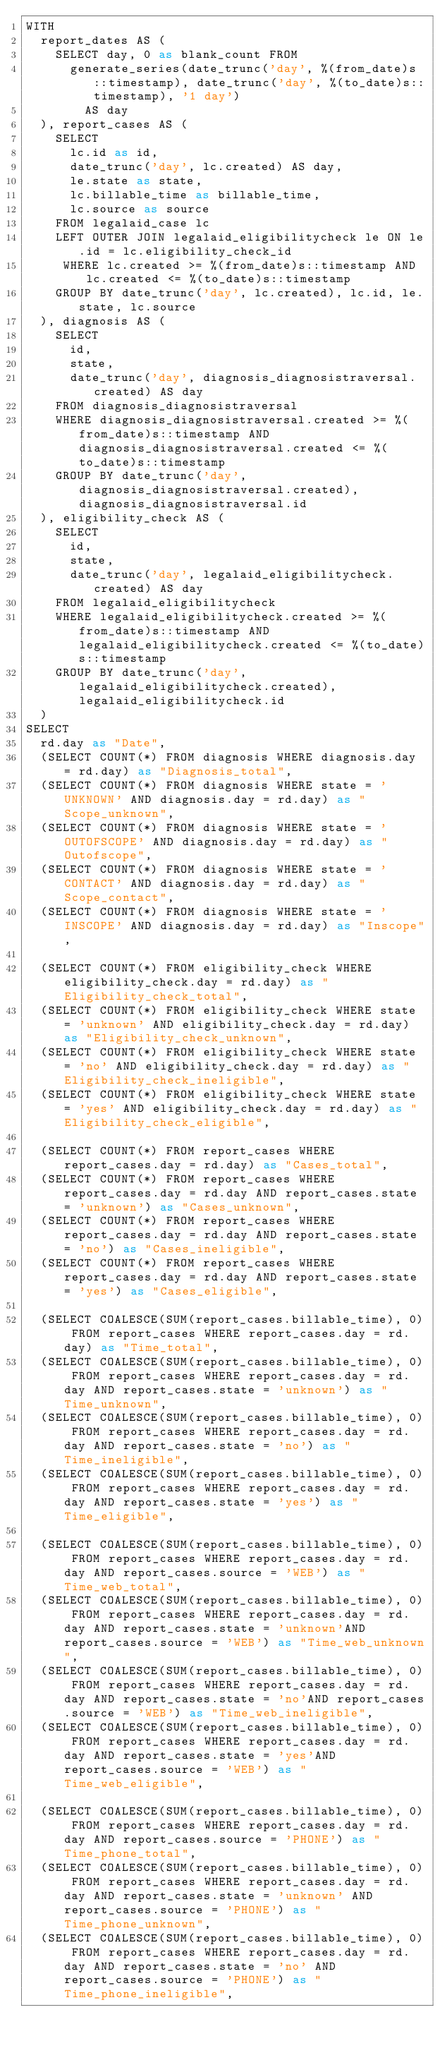<code> <loc_0><loc_0><loc_500><loc_500><_SQL_>WITH
  report_dates AS (
    SELECT day, 0 as blank_count FROM
      generate_series(date_trunc('day', %(from_date)s::timestamp), date_trunc('day', %(to_date)s::timestamp), '1 day')
        AS day
  ), report_cases AS (
    SELECT
      lc.id as id,
      date_trunc('day', lc.created) AS day,
      le.state as state,
      lc.billable_time as billable_time,
      lc.source as source
    FROM legalaid_case lc
    LEFT OUTER JOIN legalaid_eligibilitycheck le ON le.id = lc.eligibility_check_id
     WHERE lc.created >= %(from_date)s::timestamp AND lc.created <= %(to_date)s::timestamp
    GROUP BY date_trunc('day', lc.created), lc.id, le.state, lc.source
  ), diagnosis AS (
    SELECT
      id,
      state,
      date_trunc('day', diagnosis_diagnosistraversal.created) AS day
    FROM diagnosis_diagnosistraversal
    WHERE diagnosis_diagnosistraversal.created >= %(from_date)s::timestamp AND diagnosis_diagnosistraversal.created <= %(to_date)s::timestamp
    GROUP BY date_trunc('day', diagnosis_diagnosistraversal.created), diagnosis_diagnosistraversal.id
  ), eligibility_check AS (
    SELECT
      id,
      state,
      date_trunc('day', legalaid_eligibilitycheck.created) AS day
    FROM legalaid_eligibilitycheck
    WHERE legalaid_eligibilitycheck.created >= %(from_date)s::timestamp AND legalaid_eligibilitycheck.created <= %(to_date)s::timestamp
    GROUP BY date_trunc('day', legalaid_eligibilitycheck.created), legalaid_eligibilitycheck.id
  )
SELECT
  rd.day as "Date",
  (SELECT COUNT(*) FROM diagnosis WHERE diagnosis.day = rd.day) as "Diagnosis_total",
  (SELECT COUNT(*) FROM diagnosis WHERE state = 'UNKNOWN' AND diagnosis.day = rd.day) as "Scope_unknown",
  (SELECT COUNT(*) FROM diagnosis WHERE state = 'OUTOFSCOPE' AND diagnosis.day = rd.day) as "Outofscope",
  (SELECT COUNT(*) FROM diagnosis WHERE state = 'CONTACT' AND diagnosis.day = rd.day) as "Scope_contact",
  (SELECT COUNT(*) FROM diagnosis WHERE state = 'INSCOPE' AND diagnosis.day = rd.day) as "Inscope",
  
  (SELECT COUNT(*) FROM eligibility_check WHERE eligibility_check.day = rd.day) as "Eligibility_check_total",
  (SELECT COUNT(*) FROM eligibility_check WHERE state = 'unknown' AND eligibility_check.day = rd.day) as "Eligibility_check_unknown",
  (SELECT COUNT(*) FROM eligibility_check WHERE state = 'no' AND eligibility_check.day = rd.day) as "Eligibility_check_ineligible",
  (SELECT COUNT(*) FROM eligibility_check WHERE state = 'yes' AND eligibility_check.day = rd.day) as "Eligibility_check_eligible",
  
  (SELECT COUNT(*) FROM report_cases WHERE report_cases.day = rd.day) as "Cases_total",
  (SELECT COUNT(*) FROM report_cases WHERE report_cases.day = rd.day AND report_cases.state = 'unknown') as "Cases_unknown",
  (SELECT COUNT(*) FROM report_cases WHERE report_cases.day = rd.day AND report_cases.state = 'no') as "Cases_ineligible",
  (SELECT COUNT(*) FROM report_cases WHERE report_cases.day = rd.day AND report_cases.state = 'yes') as "Cases_eligible",

  (SELECT COALESCE(SUM(report_cases.billable_time), 0) FROM report_cases WHERE report_cases.day = rd.day) as "Time_total",
  (SELECT COALESCE(SUM(report_cases.billable_time), 0) FROM report_cases WHERE report_cases.day = rd.day AND report_cases.state = 'unknown') as "Time_unknown",
  (SELECT COALESCE(SUM(report_cases.billable_time), 0) FROM report_cases WHERE report_cases.day = rd.day AND report_cases.state = 'no') as "Time_ineligible",
  (SELECT COALESCE(SUM(report_cases.billable_time), 0) FROM report_cases WHERE report_cases.day = rd.day AND report_cases.state = 'yes') as "Time_eligible",

  (SELECT COALESCE(SUM(report_cases.billable_time), 0) FROM report_cases WHERE report_cases.day = rd.day AND report_cases.source = 'WEB') as "Time_web_total",
  (SELECT COALESCE(SUM(report_cases.billable_time), 0) FROM report_cases WHERE report_cases.day = rd.day AND report_cases.state = 'unknown'AND report_cases.source = 'WEB') as "Time_web_unknown",
  (SELECT COALESCE(SUM(report_cases.billable_time), 0) FROM report_cases WHERE report_cases.day = rd.day AND report_cases.state = 'no'AND report_cases.source = 'WEB') as "Time_web_ineligible",
  (SELECT COALESCE(SUM(report_cases.billable_time), 0) FROM report_cases WHERE report_cases.day = rd.day AND report_cases.state = 'yes'AND report_cases.source = 'WEB') as "Time_web_eligible",

  (SELECT COALESCE(SUM(report_cases.billable_time), 0) FROM report_cases WHERE report_cases.day = rd.day AND report_cases.source = 'PHONE') as "Time_phone_total",
  (SELECT COALESCE(SUM(report_cases.billable_time), 0) FROM report_cases WHERE report_cases.day = rd.day AND report_cases.state = 'unknown' AND report_cases.source = 'PHONE') as "Time_phone_unknown",
  (SELECT COALESCE(SUM(report_cases.billable_time), 0) FROM report_cases WHERE report_cases.day = rd.day AND report_cases.state = 'no' AND report_cases.source = 'PHONE') as "Time_phone_ineligible",</code> 